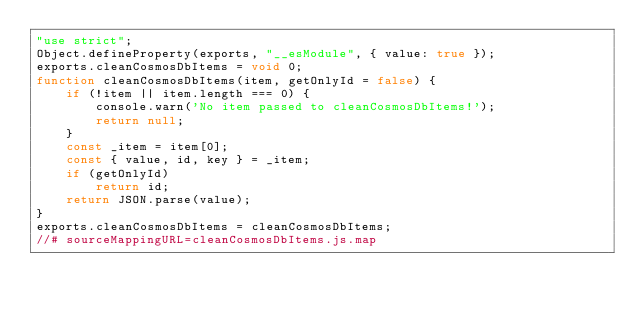Convert code to text. <code><loc_0><loc_0><loc_500><loc_500><_JavaScript_>"use strict";
Object.defineProperty(exports, "__esModule", { value: true });
exports.cleanCosmosDbItems = void 0;
function cleanCosmosDbItems(item, getOnlyId = false) {
    if (!item || item.length === 0) {
        console.warn('No item passed to cleanCosmosDbItems!');
        return null;
    }
    const _item = item[0];
    const { value, id, key } = _item;
    if (getOnlyId)
        return id;
    return JSON.parse(value);
}
exports.cleanCosmosDbItems = cleanCosmosDbItems;
//# sourceMappingURL=cleanCosmosDbItems.js.map</code> 